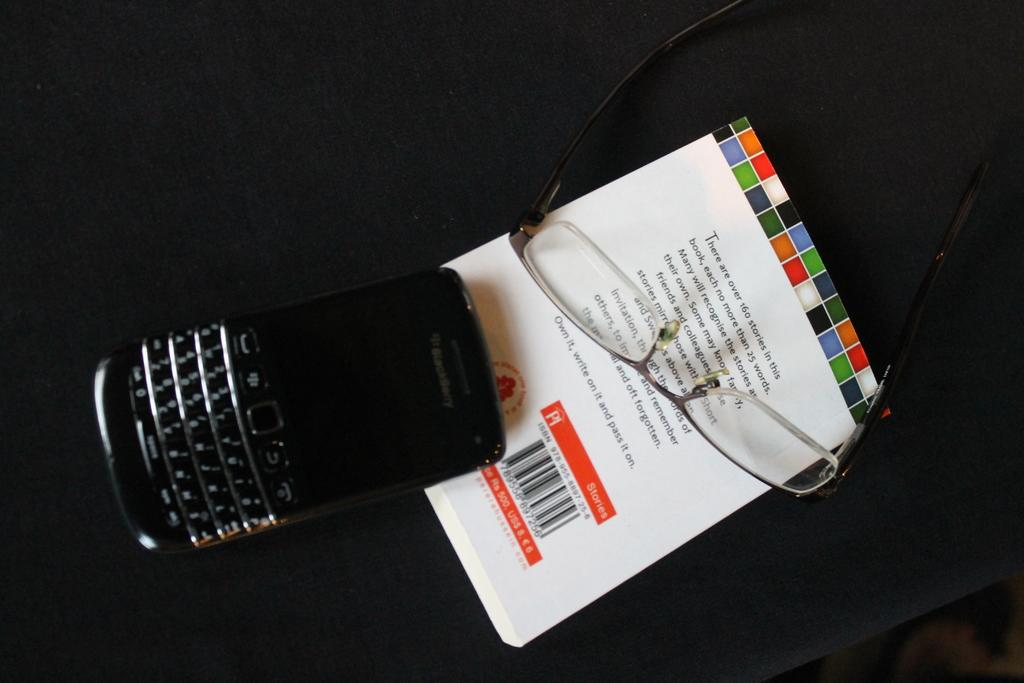What electronic device is visible in the image? There is a phone in the image. What other object can be seen in the image? There are spectacles in the image. On what object are the phone and spectacles placed? The phone and spectacles are on a book. What route does the company take to reach the destination in the image? There is no route or company present in the image; it only features a phone, spectacles, and a book. 